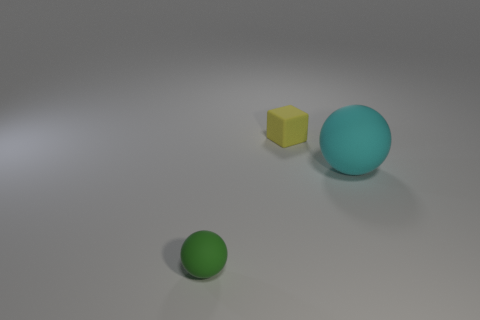Subtract 1 spheres. How many spheres are left? 1 Add 2 gray matte cylinders. How many objects exist? 5 Subtract all balls. How many objects are left? 1 Subtract all cyan balls. How many balls are left? 1 Subtract 1 green balls. How many objects are left? 2 Subtract all blue blocks. Subtract all cyan spheres. How many blocks are left? 1 Subtract all green blocks. How many purple spheres are left? 0 Subtract all tiny metal spheres. Subtract all big rubber balls. How many objects are left? 2 Add 3 large cyan spheres. How many large cyan spheres are left? 4 Add 1 rubber things. How many rubber things exist? 4 